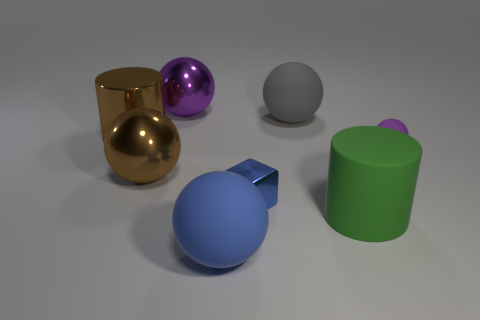Subtract all blue balls. How many balls are left? 4 Subtract 2 balls. How many balls are left? 3 Subtract all brown shiny spheres. How many spheres are left? 4 Subtract all cyan spheres. Subtract all cyan blocks. How many spheres are left? 5 Add 1 large blue matte cubes. How many objects exist? 9 Subtract all cylinders. How many objects are left? 6 Add 5 big green cylinders. How many big green cylinders are left? 6 Add 6 brown objects. How many brown objects exist? 8 Subtract 0 yellow cylinders. How many objects are left? 8 Subtract all cubes. Subtract all big purple metal balls. How many objects are left? 6 